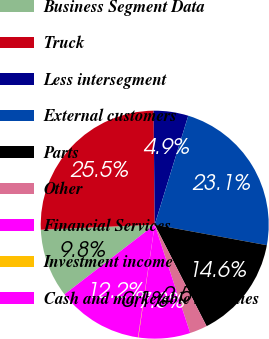Convert chart. <chart><loc_0><loc_0><loc_500><loc_500><pie_chart><fcel>Business Segment Data<fcel>Truck<fcel>Less intersegment<fcel>External customers<fcel>Parts<fcel>Other<fcel>Financial Services<fcel>Investment income<fcel>Cash and marketable securities<nl><fcel>9.76%<fcel>25.55%<fcel>4.91%<fcel>23.13%<fcel>14.6%<fcel>2.48%<fcel>7.33%<fcel>0.06%<fcel>12.18%<nl></chart> 